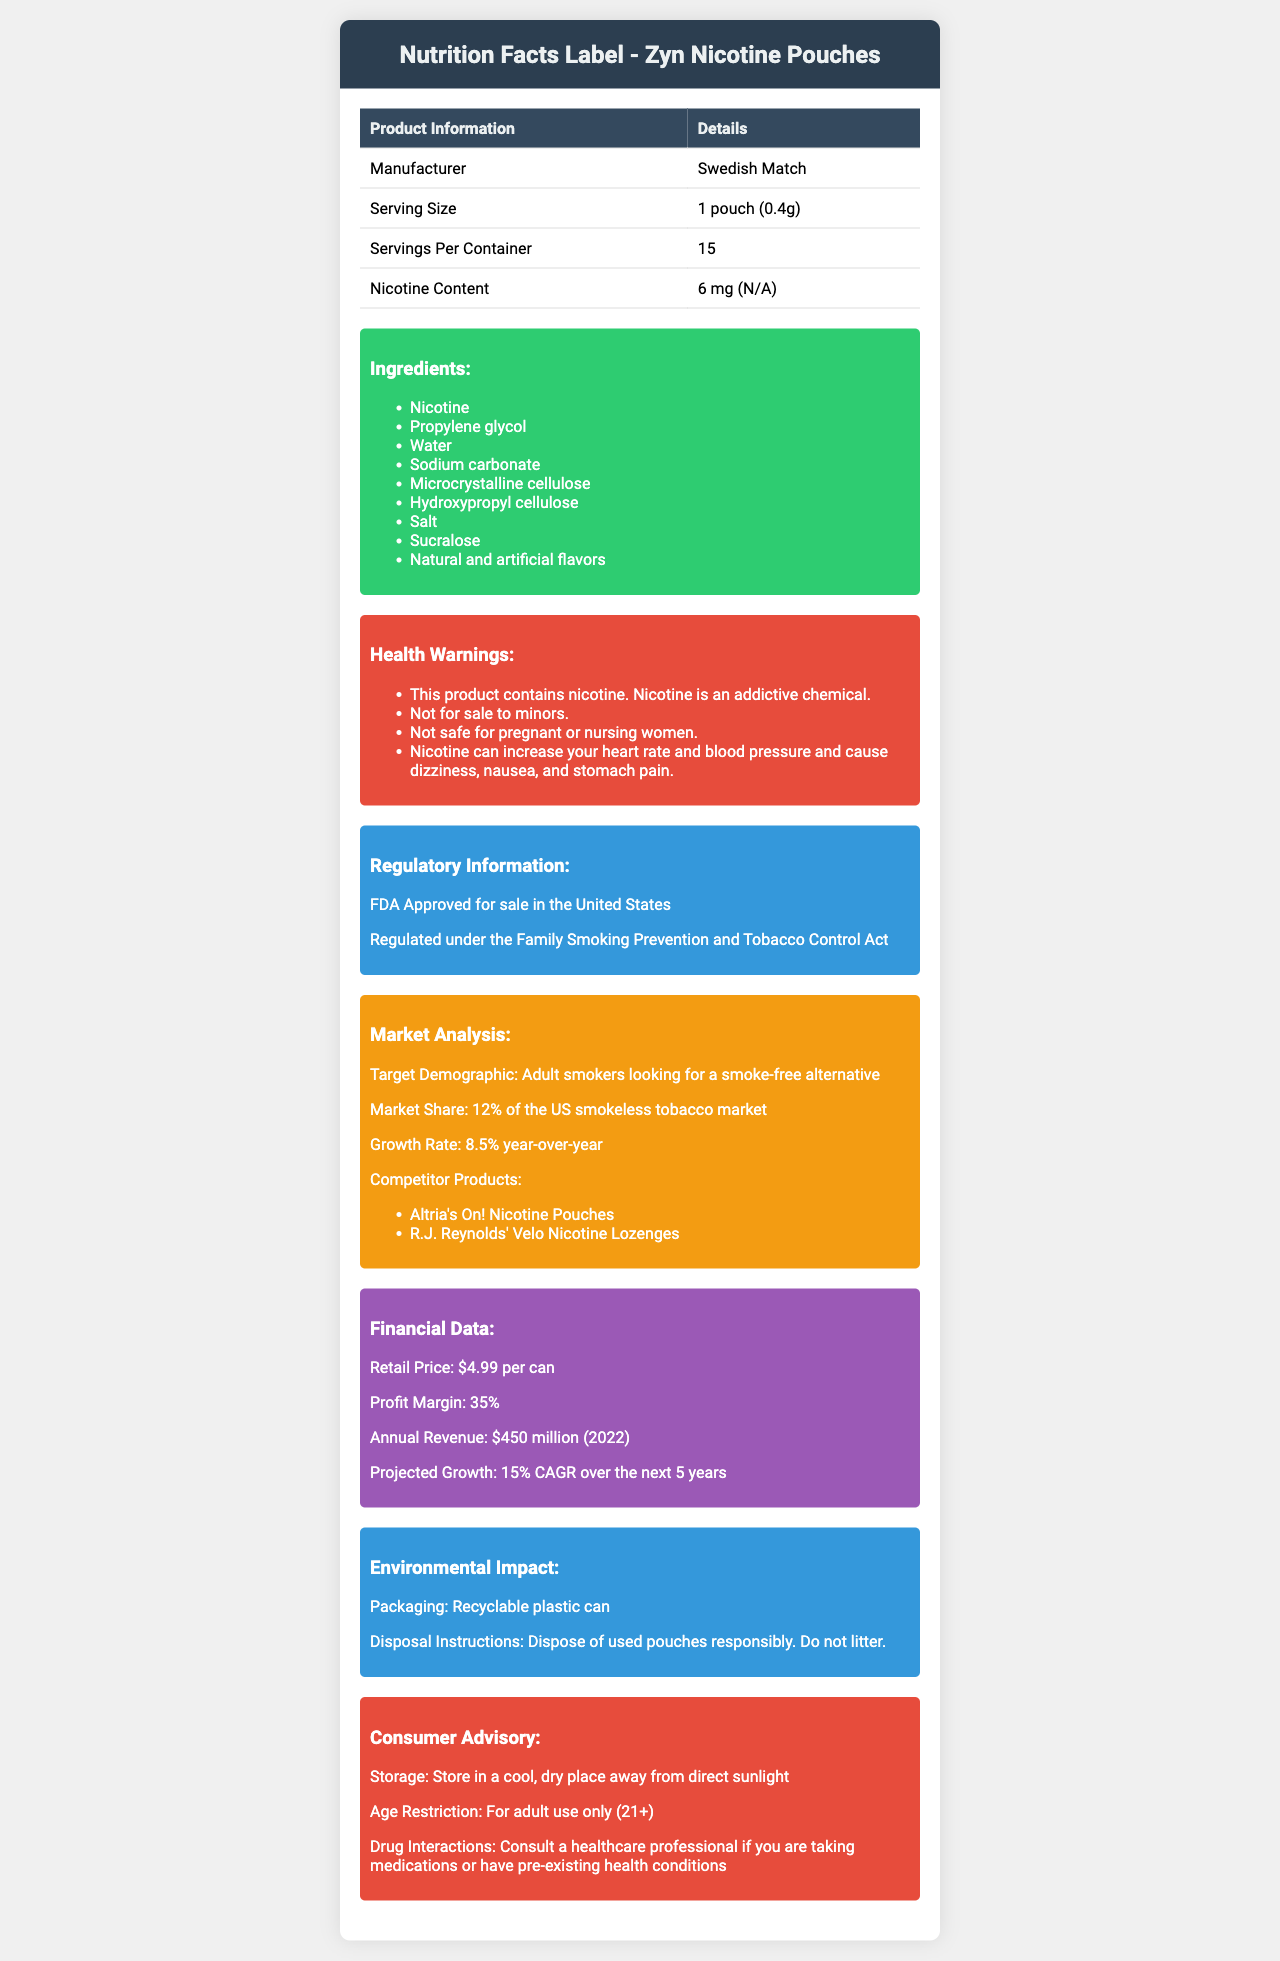what is the serving size for Zyn Nicotine Pouches? The serving size listed is 1 pouch, which weighs 0.4 grams.
Answer: 1 pouch (0.4g) who is the manufacturer of Zyn Nicotine Pouches? The document specifies that Swedish Match is the manufacturer.
Answer: Swedish Match how much nicotine is there in one serving of Zyn Nicotine Pouches? The nicotine content per serving is listed as 6 mg.
Answer: 6 mg what are the storage instructions for Zyn Nicotine Pouches? The consumer advisory section provides the storage instructions.
Answer: Store in a cool, dry place away from direct sunlight what is the retail price per can of Zyn Nicotine Pouches? The financial data section states that the retail price per can is $4.99.
Answer: $4.99 what is the market share of Zyn Nicotine Pouches in the US smokeless tobacco market? A. 10% B. 12% C. 15% The market analysis section indicates that Zyn Nicotine Pouches hold a 12% market share in the US smokeless tobacco market.
Answer: B which of the following is a competitor product mentioned in the document? A. Altria's On! Nicotine Pouches B. Juul Vape Pods C. Philip Morris IQOS The market analysis section lists Altria's On! Nicotine Pouches as a competitor product.
Answer: A were Zyn Nicotine Pouches FDA approved for sale in the US? Yes/No The regulatory information section states that the product is FDA approved for sale in the United States.
Answer: Yes summarize the main ideas presented in the document. The document covers various aspects of Zyn Nicotine Pouches, from nutritional details and health warnings to market performance and environmental information, giving a comprehensive overview of the product.
Answer: The document provides a detailed overview of Zyn Nicotine Pouches, manufactured by Swedish Match. It includes nutritional information, ingredients, health warnings, regulatory information, market analysis, financial data, environmental impact, and consumer advisory details. The product targets adult smokers looking for a smokeless alternative and holds a 12% market share in the US smokeless tobacco market, with a retail price of $4.99 per can and projected significant growth. what is the annual revenue for Zyn Nicotine Pouches in 2022? The financial data section states that the annual revenue in 2022 was $450 million.
Answer: $450 million what percentage of smokers does Zyn Nicotine Pouches target? The market analysis section mentions the target demographic as adult smokers looking for a smoke-free alternative, but it does not provide a specific percentage of the smokers they target.
Answer: Not enough information name three ingredients listed in Zyn Nicotine Pouches. The ingredients section lists Nicotine, Propylene glycol, and Water among other ingredients.
Answer: Nicotine, Propylene glycol, Water which statement is true about the nicotine effects according to the health warnings? A. Nicotine decreases heart rate B. Nicotine is not addictive C. Nicotine can cause dizziness and nausea The health warnings state that nicotine can increase heart rate and blood pressure and cause dizziness, nausea, and stomach pain.
Answer: C are Zyn Nicotine Pouches safe for pregnant or nursing women? The health warnings explicitly state that the product is not safe for pregnant or nursing women.
Answer: No what is the projected growth rate for Zyn Nicotine Pouches over the next 5 years? The financial data section predicts a 15% compound annual growth rate over the next 5 years.
Answer: 15% CAGR 